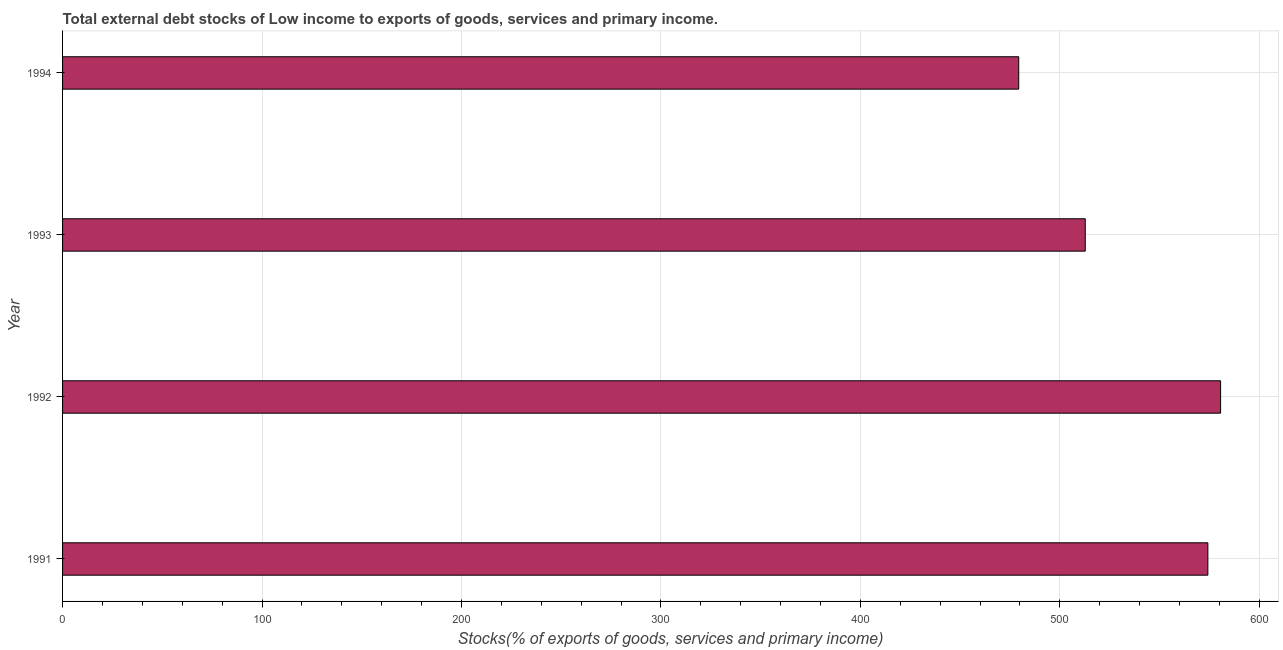Does the graph contain grids?
Give a very brief answer. Yes. What is the title of the graph?
Your answer should be very brief. Total external debt stocks of Low income to exports of goods, services and primary income. What is the label or title of the X-axis?
Your answer should be very brief. Stocks(% of exports of goods, services and primary income). What is the external debt stocks in 1993?
Your answer should be compact. 512.78. Across all years, what is the maximum external debt stocks?
Provide a succinct answer. 580.63. Across all years, what is the minimum external debt stocks?
Make the answer very short. 479.42. In which year was the external debt stocks maximum?
Your answer should be very brief. 1992. In which year was the external debt stocks minimum?
Your answer should be very brief. 1994. What is the sum of the external debt stocks?
Offer a terse response. 2147.08. What is the difference between the external debt stocks in 1991 and 1992?
Your answer should be very brief. -6.39. What is the average external debt stocks per year?
Offer a very short reply. 536.77. What is the median external debt stocks?
Your answer should be very brief. 543.51. Do a majority of the years between 1991 and 1993 (inclusive) have external debt stocks greater than 580 %?
Provide a succinct answer. No. What is the ratio of the external debt stocks in 1991 to that in 1994?
Ensure brevity in your answer.  1.2. Is the difference between the external debt stocks in 1992 and 1994 greater than the difference between any two years?
Your response must be concise. Yes. What is the difference between the highest and the second highest external debt stocks?
Make the answer very short. 6.39. What is the difference between the highest and the lowest external debt stocks?
Keep it short and to the point. 101.21. In how many years, is the external debt stocks greater than the average external debt stocks taken over all years?
Provide a succinct answer. 2. Are all the bars in the graph horizontal?
Your response must be concise. Yes. What is the difference between two consecutive major ticks on the X-axis?
Provide a succinct answer. 100. Are the values on the major ticks of X-axis written in scientific E-notation?
Ensure brevity in your answer.  No. What is the Stocks(% of exports of goods, services and primary income) in 1991?
Your answer should be compact. 574.24. What is the Stocks(% of exports of goods, services and primary income) in 1992?
Keep it short and to the point. 580.63. What is the Stocks(% of exports of goods, services and primary income) of 1993?
Keep it short and to the point. 512.78. What is the Stocks(% of exports of goods, services and primary income) in 1994?
Offer a terse response. 479.42. What is the difference between the Stocks(% of exports of goods, services and primary income) in 1991 and 1992?
Keep it short and to the point. -6.39. What is the difference between the Stocks(% of exports of goods, services and primary income) in 1991 and 1993?
Your answer should be very brief. 61.46. What is the difference between the Stocks(% of exports of goods, services and primary income) in 1991 and 1994?
Your answer should be compact. 94.82. What is the difference between the Stocks(% of exports of goods, services and primary income) in 1992 and 1993?
Keep it short and to the point. 67.85. What is the difference between the Stocks(% of exports of goods, services and primary income) in 1992 and 1994?
Offer a terse response. 101.21. What is the difference between the Stocks(% of exports of goods, services and primary income) in 1993 and 1994?
Make the answer very short. 33.36. What is the ratio of the Stocks(% of exports of goods, services and primary income) in 1991 to that in 1993?
Your response must be concise. 1.12. What is the ratio of the Stocks(% of exports of goods, services and primary income) in 1991 to that in 1994?
Ensure brevity in your answer.  1.2. What is the ratio of the Stocks(% of exports of goods, services and primary income) in 1992 to that in 1993?
Offer a very short reply. 1.13. What is the ratio of the Stocks(% of exports of goods, services and primary income) in 1992 to that in 1994?
Your answer should be compact. 1.21. What is the ratio of the Stocks(% of exports of goods, services and primary income) in 1993 to that in 1994?
Give a very brief answer. 1.07. 